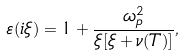Convert formula to latex. <formula><loc_0><loc_0><loc_500><loc_500>\varepsilon ( i \xi ) = 1 + \frac { \omega _ { p } ^ { 2 } } { \xi [ \xi + \nu ( T ) ] } ,</formula> 